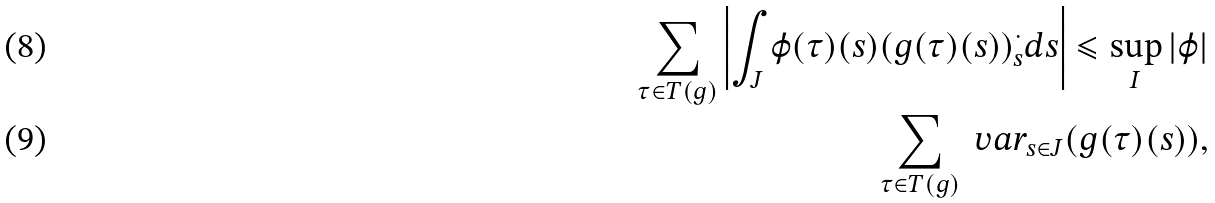Convert formula to latex. <formula><loc_0><loc_0><loc_500><loc_500>\sum _ { \tau \in T ( g ) } \left | \int _ { J } \varphi ( \tau ) ( s ) ( g ( \tau ) ( s ) ) ^ { \cdot } _ { s } d s \right | \leqslant \sup _ { I } | \varphi | \\ \sum _ { \tau \in T ( g ) } \ v a r _ { s \in J } ( g ( \tau ) ( s ) ) ,</formula> 